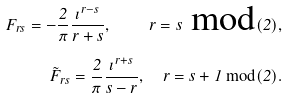<formula> <loc_0><loc_0><loc_500><loc_500>F _ { r s } = - \frac { 2 } { \pi } \frac { \imath ^ { r - s } } { r + s } , \quad r = s \text { mod} ( 2 ) , \\ \tilde { F } _ { r s } = \frac { 2 } { \pi } \frac { \imath ^ { r + s } } { s - r } , \quad r = s + 1 \text { mod} ( 2 ) .</formula> 